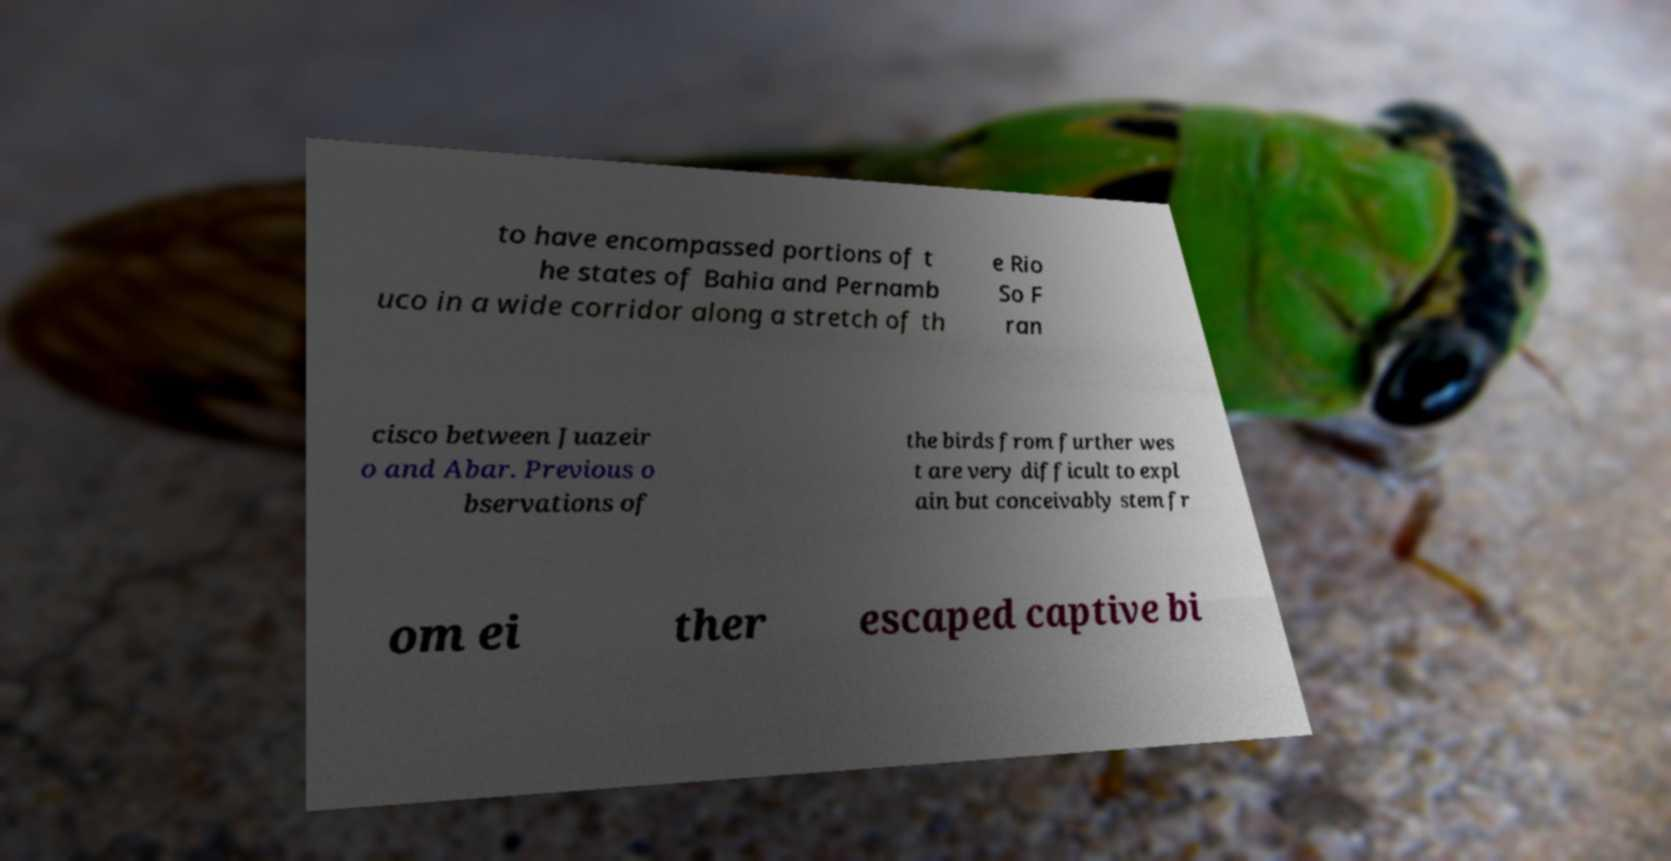Please identify and transcribe the text found in this image. to have encompassed portions of t he states of Bahia and Pernamb uco in a wide corridor along a stretch of th e Rio So F ran cisco between Juazeir o and Abar. Previous o bservations of the birds from further wes t are very difficult to expl ain but conceivably stem fr om ei ther escaped captive bi 